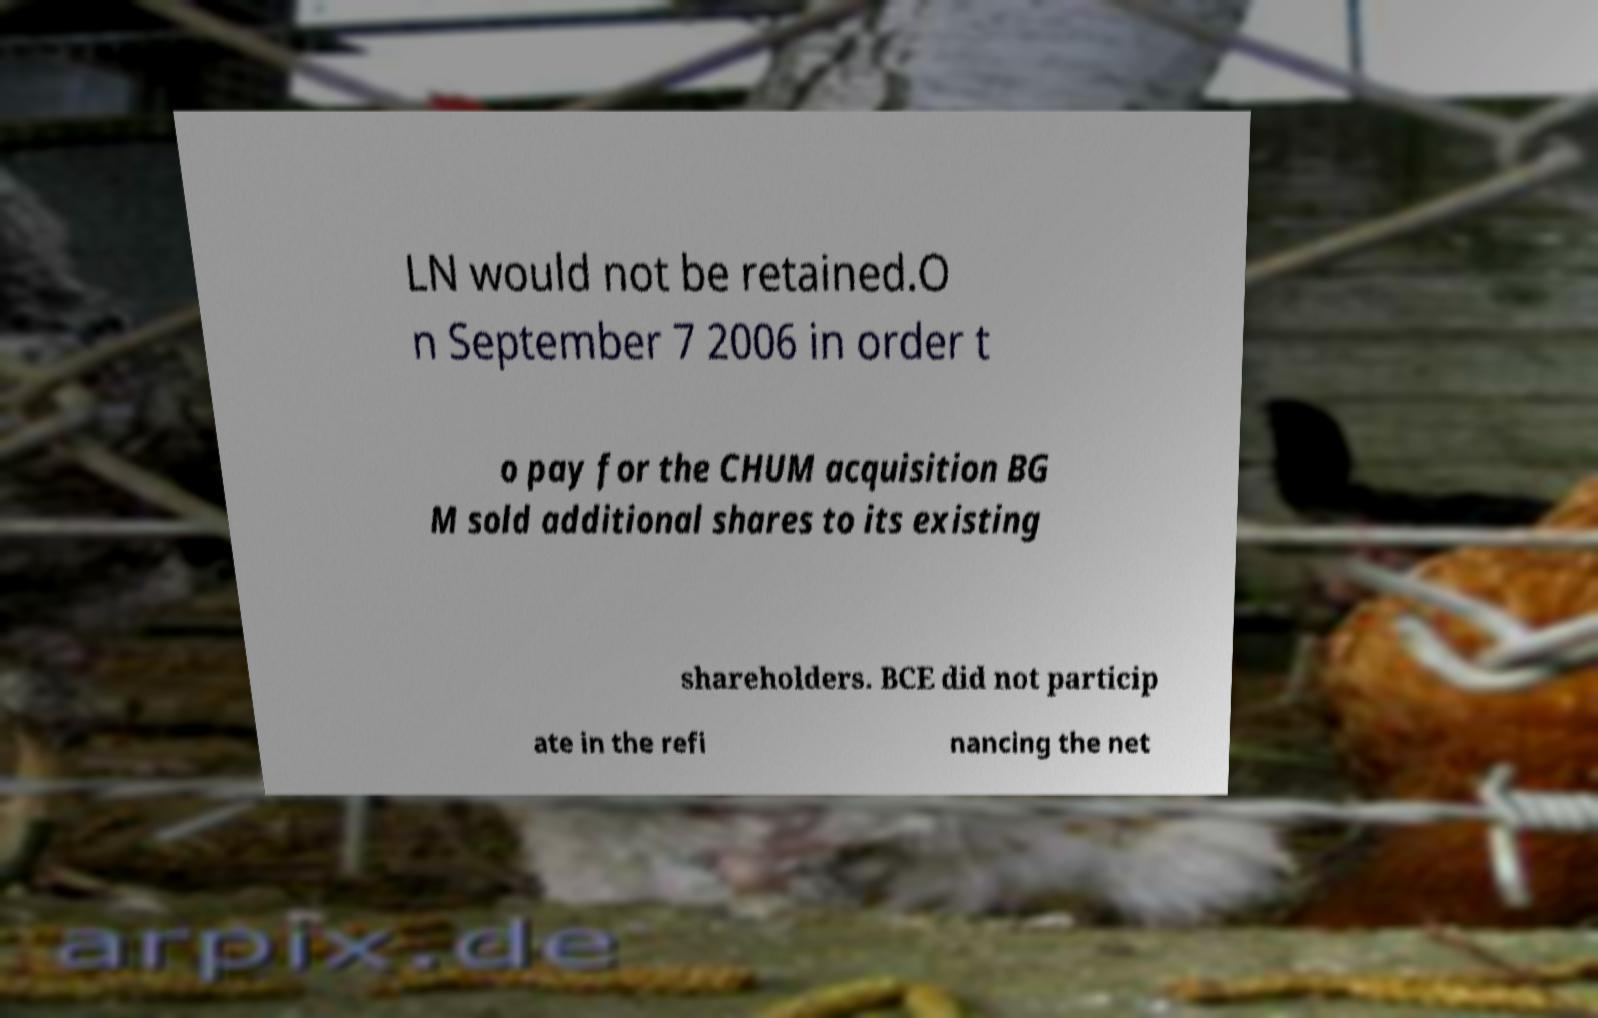There's text embedded in this image that I need extracted. Can you transcribe it verbatim? LN would not be retained.O n September 7 2006 in order t o pay for the CHUM acquisition BG M sold additional shares to its existing shareholders. BCE did not particip ate in the refi nancing the net 